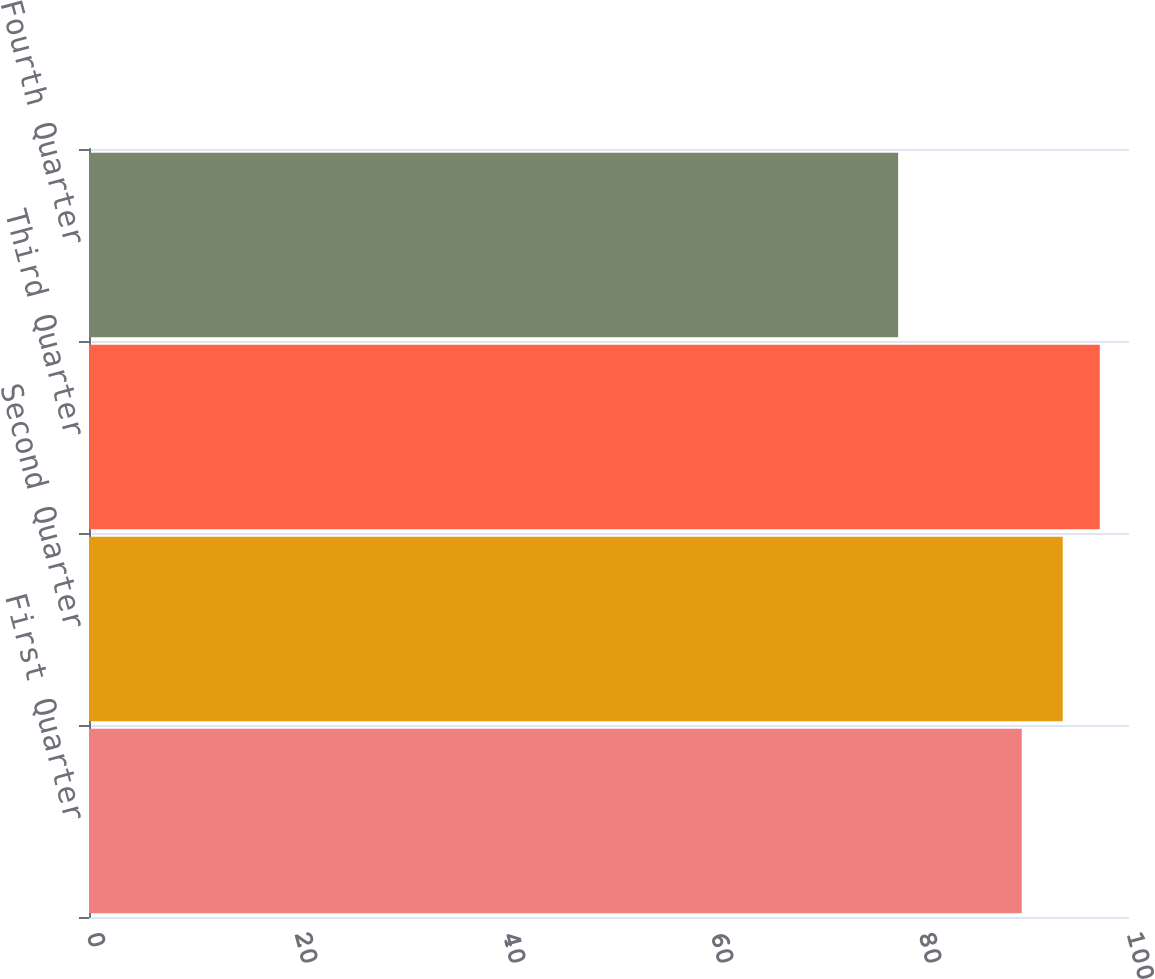<chart> <loc_0><loc_0><loc_500><loc_500><bar_chart><fcel>First Quarter<fcel>Second Quarter<fcel>Third Quarter<fcel>Fourth Quarter<nl><fcel>89.69<fcel>93.63<fcel>97.19<fcel>77.8<nl></chart> 